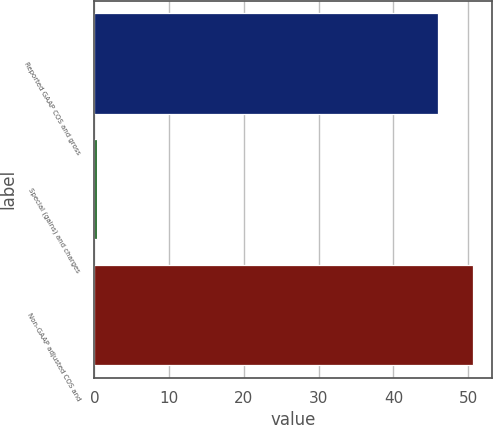Convert chart to OTSL. <chart><loc_0><loc_0><loc_500><loc_500><bar_chart><fcel>Reported GAAP COS and gross<fcel>Special (gains) and charges<fcel>Non-GAAP adjusted COS and<nl><fcel>46<fcel>0.3<fcel>50.6<nl></chart> 